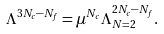Convert formula to latex. <formula><loc_0><loc_0><loc_500><loc_500>\Lambda ^ { 3 N _ { c } - N _ { f } } = \mu ^ { N _ { c } } \Lambda _ { N = 2 } ^ { 2 N _ { c } - N _ { f } } .</formula> 